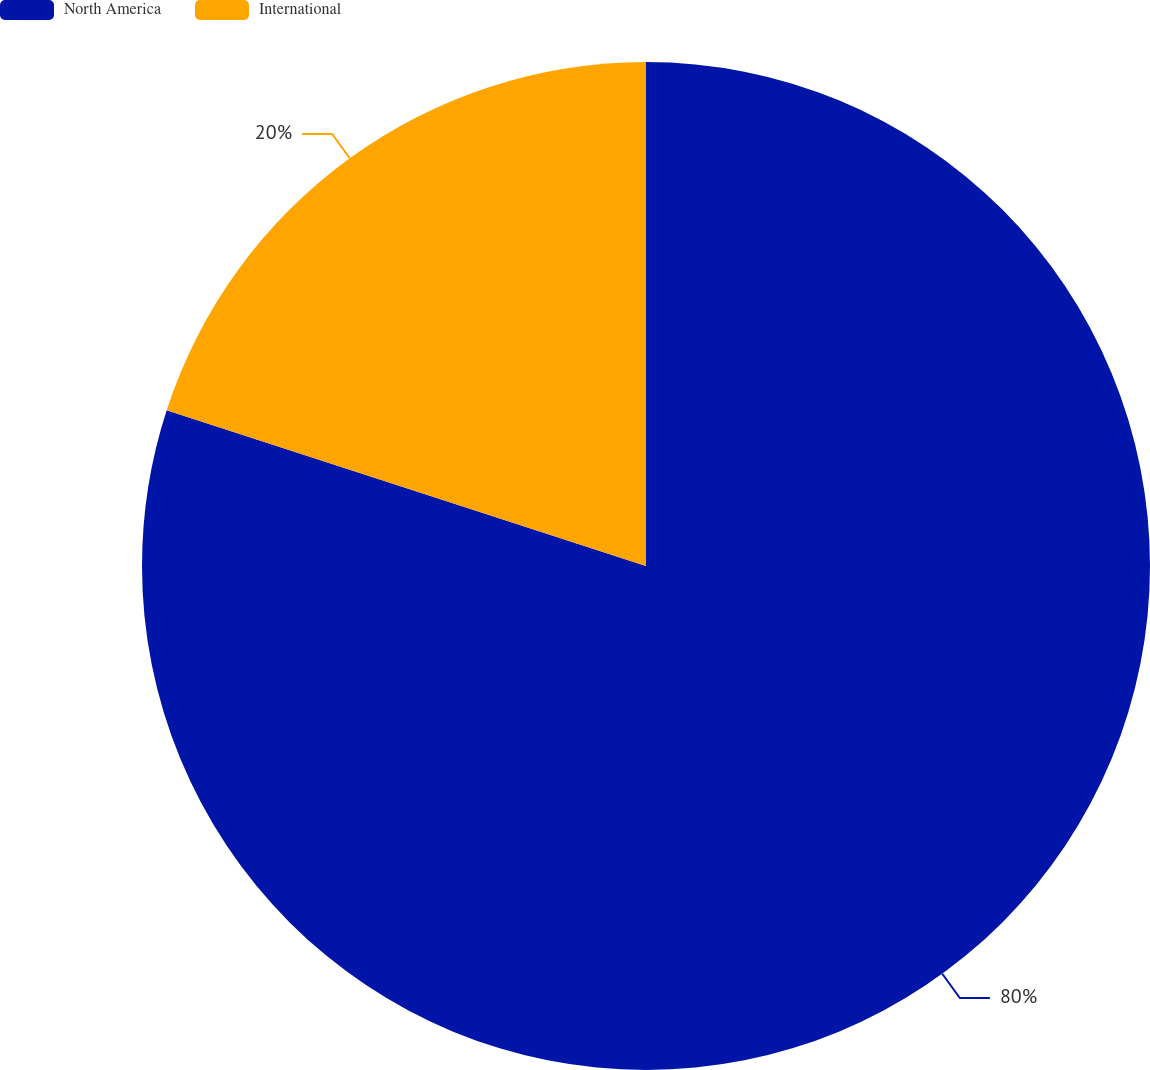<chart> <loc_0><loc_0><loc_500><loc_500><pie_chart><fcel>North America<fcel>International<nl><fcel>80.0%<fcel>20.0%<nl></chart> 